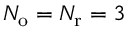<formula> <loc_0><loc_0><loc_500><loc_500>{ N _ { o } } = { N _ { r } } = 3</formula> 